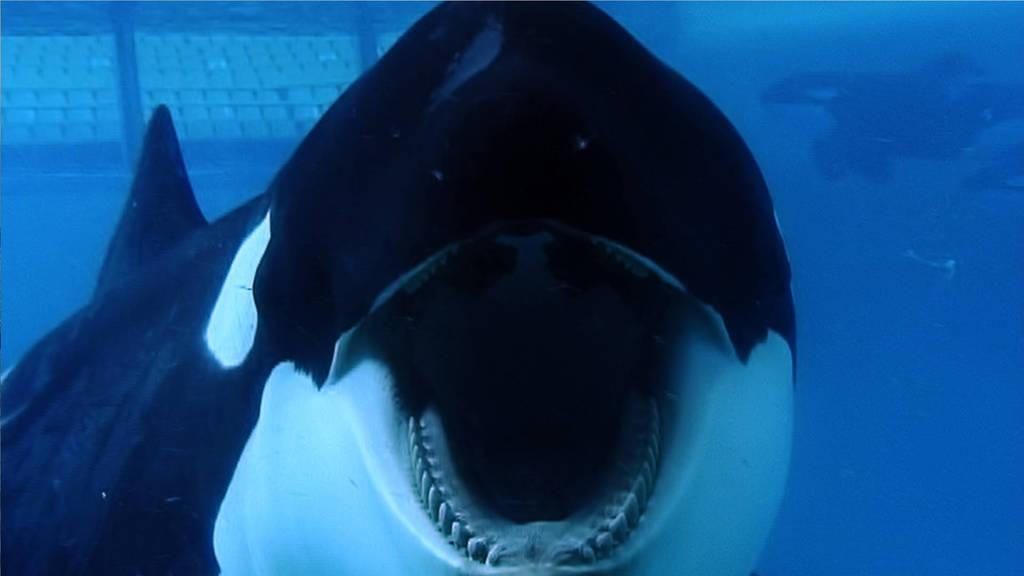What type of animal is in the image? There is a shark fish in the image. How close is the view of the shark fish? The view of the shark fish is close. Where is the shark fish located in the image? The shark fish is underwater in the image. What type of slope can be seen in the image? There is no slope present in the image; it features a shark fish underwater. 